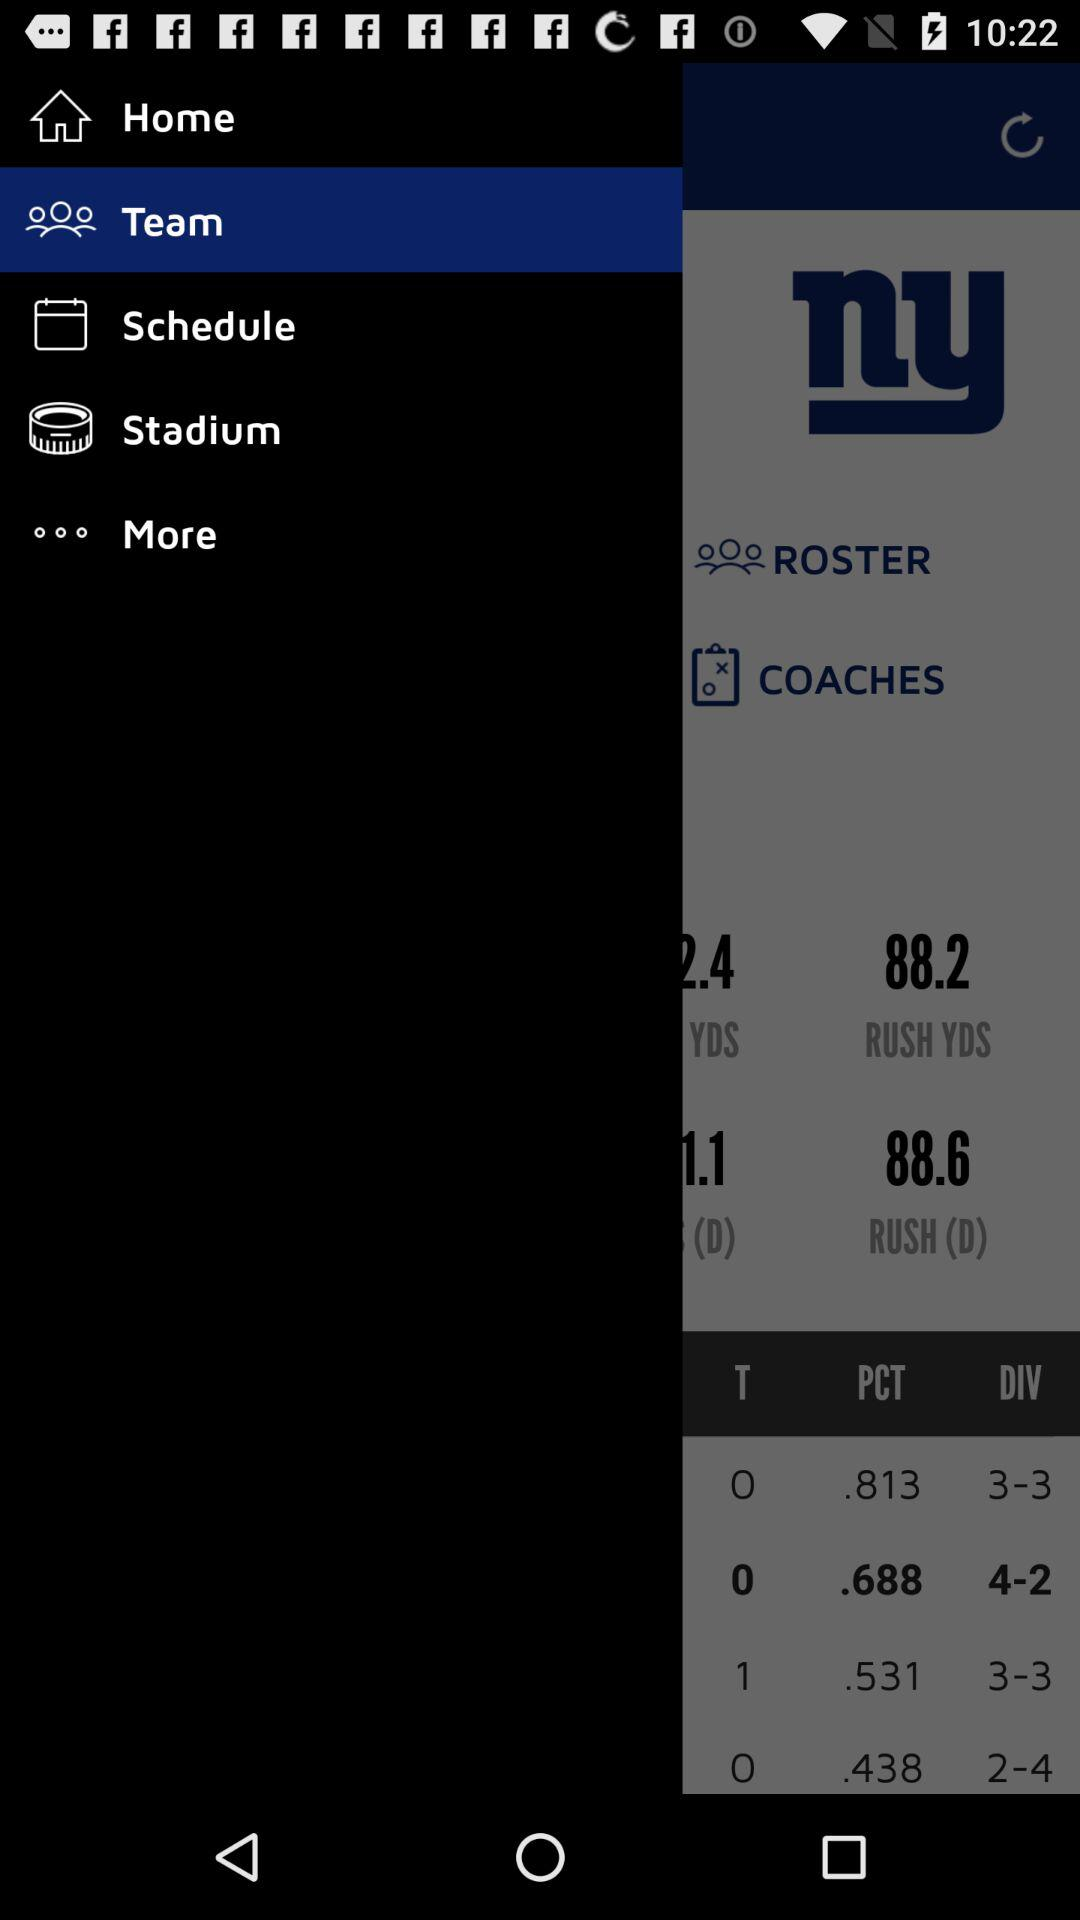What is the record of the team with the .813 winning percentage?
Answer the question using a single word or phrase. 3-3 